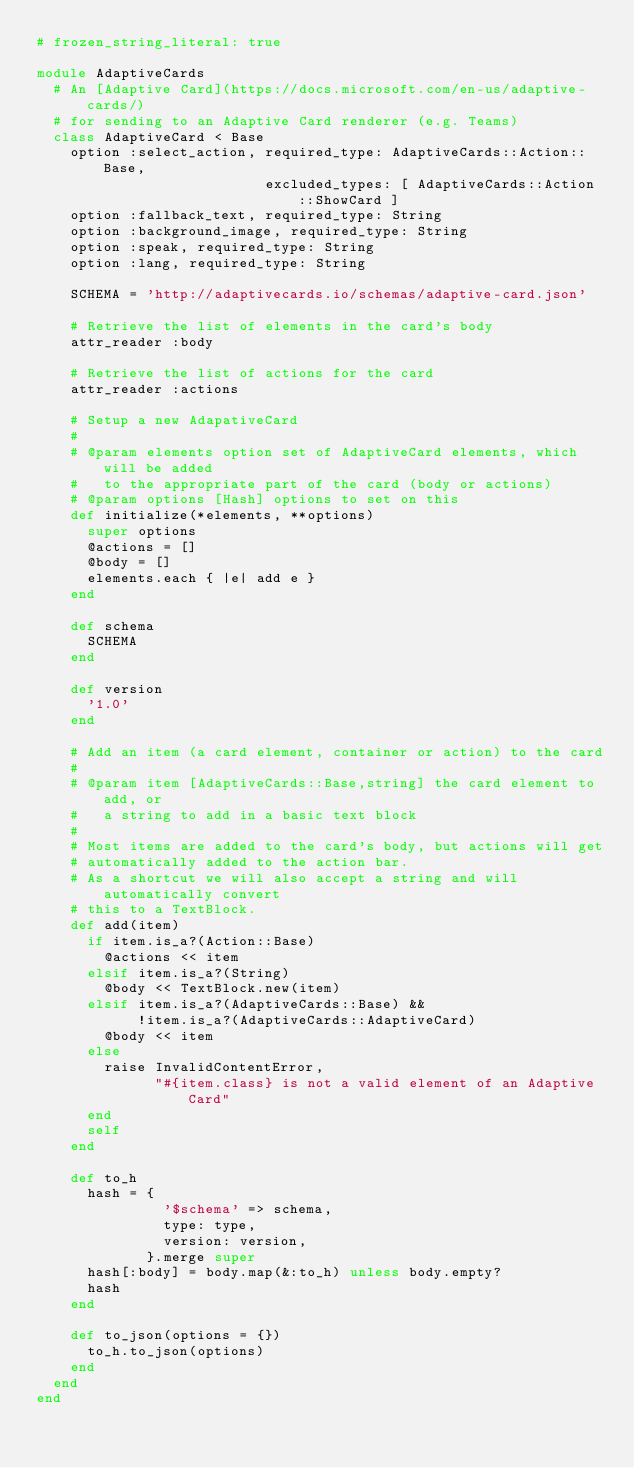<code> <loc_0><loc_0><loc_500><loc_500><_Ruby_># frozen_string_literal: true

module AdaptiveCards
  # An [Adaptive Card](https://docs.microsoft.com/en-us/adaptive-cards/)
  # for sending to an Adaptive Card renderer (e.g. Teams)
  class AdaptiveCard < Base
    option :select_action, required_type: AdaptiveCards::Action::Base,
                           excluded_types: [ AdaptiveCards::Action::ShowCard ]
    option :fallback_text, required_type: String
    option :background_image, required_type: String
    option :speak, required_type: String
    option :lang, required_type: String

    SCHEMA = 'http://adaptivecards.io/schemas/adaptive-card.json'

    # Retrieve the list of elements in the card's body
    attr_reader :body
    
    # Retrieve the list of actions for the card
    attr_reader :actions

    # Setup a new AdapativeCard
    #
    # @param elements option set of AdaptiveCard elements, which will be added
    #   to the appropriate part of the card (body or actions)
    # @param options [Hash] options to set on this
    def initialize(*elements, **options)
      super options
      @actions = []
      @body = []
      elements.each { |e| add e }
    end

    def schema
      SCHEMA
    end

    def version
      '1.0'
    end

    # Add an item (a card element, container or action) to the card
    #
    # @param item [AdaptiveCards::Base,string] the card element to add, or
    #   a string to add in a basic text block
    #
    # Most items are added to the card's body, but actions will get
    # automatically added to the action bar.
    # As a shortcut we will also accept a string and will automatically convert
    # this to a TextBlock.
    def add(item)
      if item.is_a?(Action::Base)
        @actions << item
      elsif item.is_a?(String)
        @body << TextBlock.new(item)
      elsif item.is_a?(AdaptiveCards::Base) &&
            !item.is_a?(AdaptiveCards::AdaptiveCard)
        @body << item
      else
        raise InvalidContentError,
              "#{item.class} is not a valid element of an Adaptive Card"
      end
      self
    end

    def to_h
      hash = {
               '$schema' => schema,
               type: type,
               version: version,
             }.merge super
      hash[:body] = body.map(&:to_h) unless body.empty?
      hash
    end

    def to_json(options = {})
      to_h.to_json(options)
    end
  end
end
</code> 